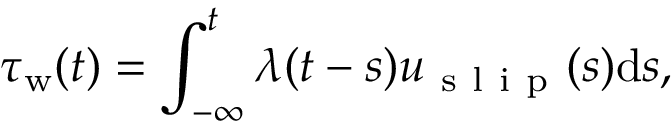<formula> <loc_0><loc_0><loc_500><loc_500>\tau _ { w } ( t ) = \int _ { - \infty } ^ { t } \lambda ( t - s ) u _ { s l i p } ( s ) d s ,</formula> 